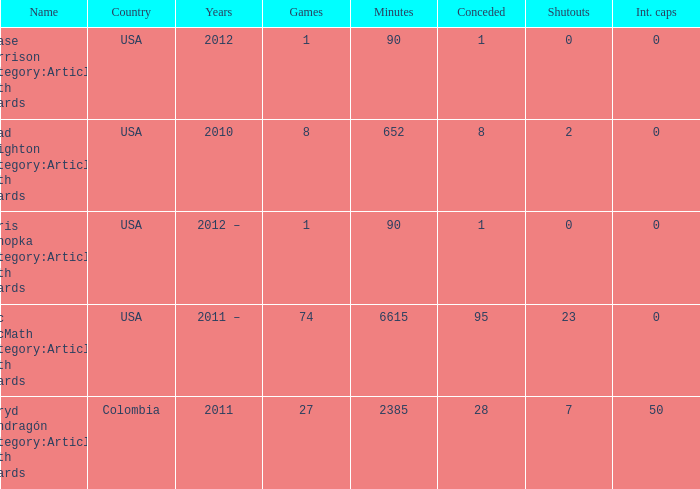What is the lowest overall amount of shutouts? 0.0. 